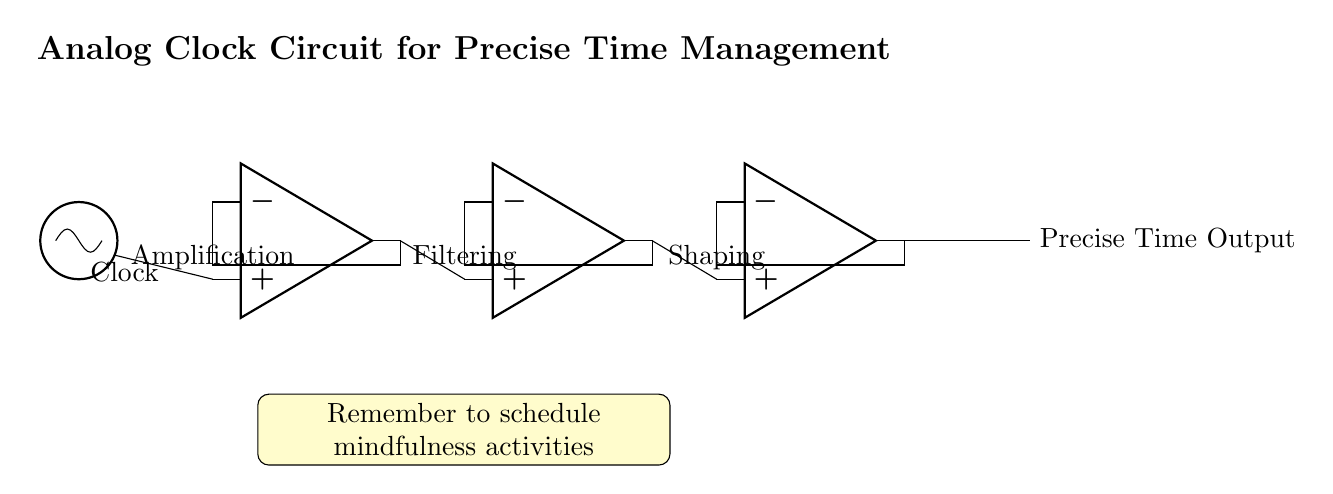What type of circuit is depicted? The circuit is an analog circuit designed for precise time management, as indicated by the components and the specific purpose stated in the title.
Answer: Analog How many operational amplifiers are used? There are three operational amplifiers shown in the circuit diagram, as represented by the three op amp icons.
Answer: Three What function does the first operational amplifier serve? The first operational amplifier is labeled "Amplification," indicating that its purpose in the circuit is to amplify the incoming clock signal.
Answer: Amplification What is the output of the third operational amplifier? The output of the third operational amplifier is labeled "Precise Time Output," which indicates that it provides the precise time as the final output of the circuit.
Answer: Precise Time Output Why is filtering necessary in this circuit? Filtering is necessary to remove any unwanted noise from the amplified signal before shaping it, as indicated by the second op amp's label "Filtering," which is a crucial step for maintaining signal integrity.
Answer: To remove noise What is the primary purpose of the circuit? The primary purpose of the circuit is to manage time precisely, as stated in the title, which is essential for scheduling and timekeeping applications.
Answer: Precise time management 